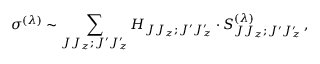Convert formula to latex. <formula><loc_0><loc_0><loc_500><loc_500>\sigma ^ { ( \lambda ) } \sim \sum _ { J J _ { z } ; J ^ { \prime } J _ { z } ^ { \prime } } H _ { J J _ { z } ; J ^ { \prime } J _ { z } ^ { \prime } } \cdot S _ { J J _ { z } ; J ^ { \prime } J _ { z } ^ { \prime } } ^ { ( \lambda ) } \, ,</formula> 